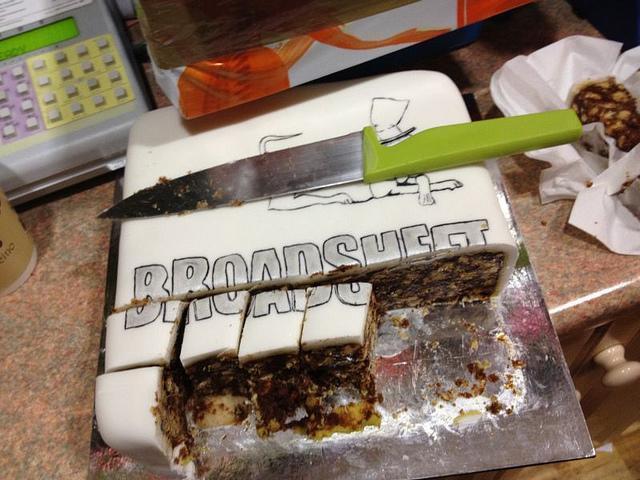How many pieces of cake are already cut?
Give a very brief answer. 5. How many cakes can be seen?
Give a very brief answer. 4. 